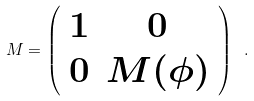<formula> <loc_0><loc_0><loc_500><loc_500>M = \left ( \begin{array} { c c } 1 & 0 \\ 0 & M ( \phi ) \\ \end{array} \right ) \ .</formula> 